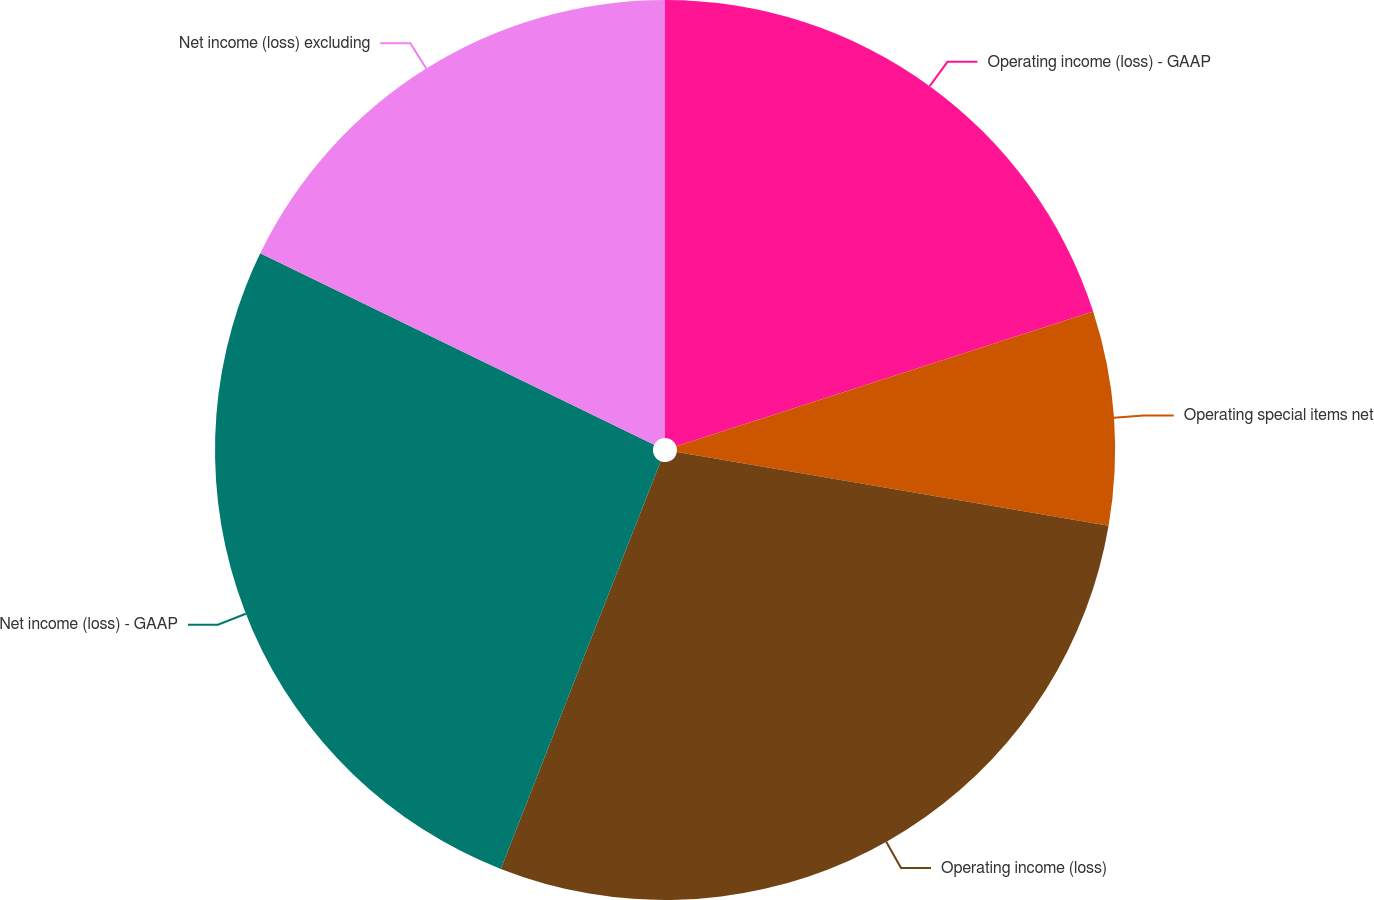Convert chart to OTSL. <chart><loc_0><loc_0><loc_500><loc_500><pie_chart><fcel>Operating income (loss) - GAAP<fcel>Operating special items net<fcel>Operating income (loss)<fcel>Net income (loss) - GAAP<fcel>Net income (loss) excluding<nl><fcel>20.02%<fcel>7.67%<fcel>28.25%<fcel>26.25%<fcel>17.8%<nl></chart> 